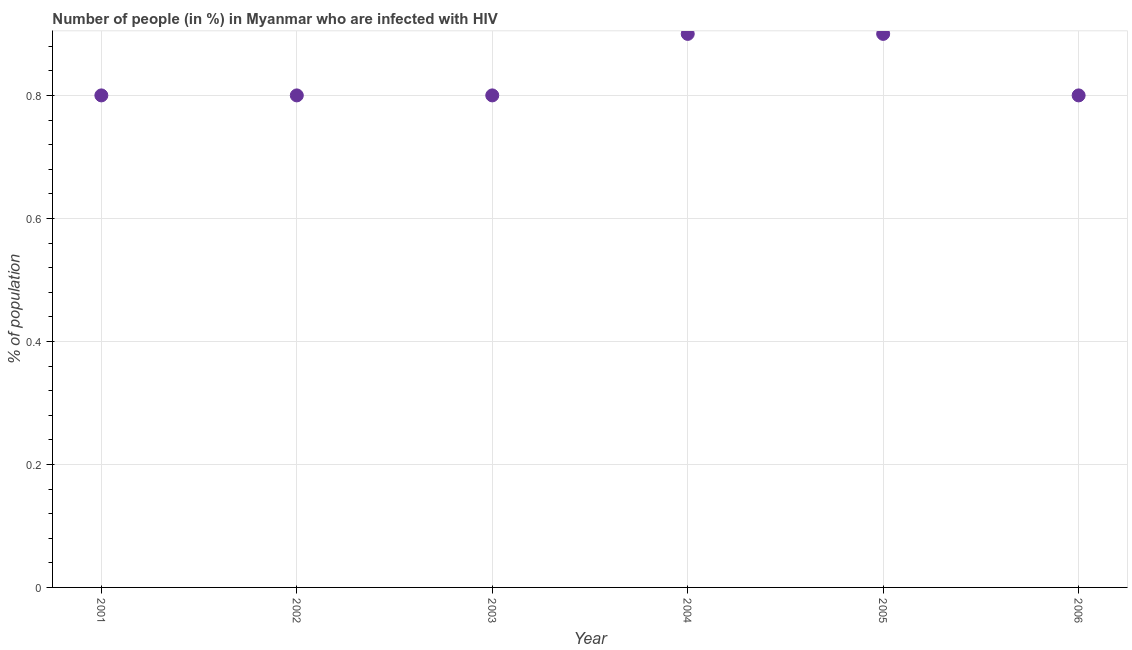In which year was the number of people infected with hiv maximum?
Keep it short and to the point. 2004. What is the sum of the number of people infected with hiv?
Your response must be concise. 5. What is the difference between the number of people infected with hiv in 2001 and 2002?
Give a very brief answer. 0. What is the average number of people infected with hiv per year?
Ensure brevity in your answer.  0.83. In how many years, is the number of people infected with hiv greater than 0.12 %?
Provide a succinct answer. 6. What is the ratio of the number of people infected with hiv in 2003 to that in 2006?
Make the answer very short. 1. Is the difference between the number of people infected with hiv in 2003 and 2006 greater than the difference between any two years?
Offer a terse response. No. Is the sum of the number of people infected with hiv in 2003 and 2006 greater than the maximum number of people infected with hiv across all years?
Provide a succinct answer. Yes. What is the difference between the highest and the lowest number of people infected with hiv?
Provide a succinct answer. 0.1. How many years are there in the graph?
Offer a terse response. 6. Are the values on the major ticks of Y-axis written in scientific E-notation?
Your answer should be very brief. No. What is the title of the graph?
Ensure brevity in your answer.  Number of people (in %) in Myanmar who are infected with HIV. What is the label or title of the X-axis?
Your response must be concise. Year. What is the label or title of the Y-axis?
Your response must be concise. % of population. What is the % of population in 2001?
Give a very brief answer. 0.8. What is the % of population in 2005?
Make the answer very short. 0.9. What is the difference between the % of population in 2001 and 2003?
Your response must be concise. 0. What is the difference between the % of population in 2001 and 2004?
Offer a terse response. -0.1. What is the difference between the % of population in 2001 and 2006?
Ensure brevity in your answer.  0. What is the difference between the % of population in 2002 and 2003?
Ensure brevity in your answer.  0. What is the difference between the % of population in 2002 and 2004?
Offer a very short reply. -0.1. What is the difference between the % of population in 2003 and 2006?
Provide a succinct answer. 0. What is the difference between the % of population in 2004 and 2006?
Your answer should be very brief. 0.1. What is the ratio of the % of population in 2001 to that in 2003?
Provide a succinct answer. 1. What is the ratio of the % of population in 2001 to that in 2004?
Offer a very short reply. 0.89. What is the ratio of the % of population in 2001 to that in 2005?
Give a very brief answer. 0.89. What is the ratio of the % of population in 2001 to that in 2006?
Provide a succinct answer. 1. What is the ratio of the % of population in 2002 to that in 2004?
Make the answer very short. 0.89. What is the ratio of the % of population in 2002 to that in 2005?
Ensure brevity in your answer.  0.89. What is the ratio of the % of population in 2003 to that in 2004?
Give a very brief answer. 0.89. What is the ratio of the % of population in 2003 to that in 2005?
Make the answer very short. 0.89. What is the ratio of the % of population in 2004 to that in 2006?
Provide a succinct answer. 1.12. 